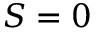Convert formula to latex. <formula><loc_0><loc_0><loc_500><loc_500>S = 0</formula> 